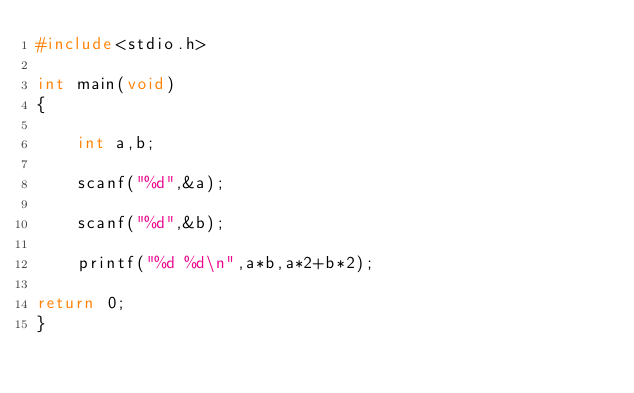<code> <loc_0><loc_0><loc_500><loc_500><_C_>#include<stdio.h>

int main(void)
{

	int a,b;

	scanf("%d",&a);

	scanf("%d",&b);

	printf("%d %d\n",a*b,a*2+b*2);

return 0;
}
</code> 